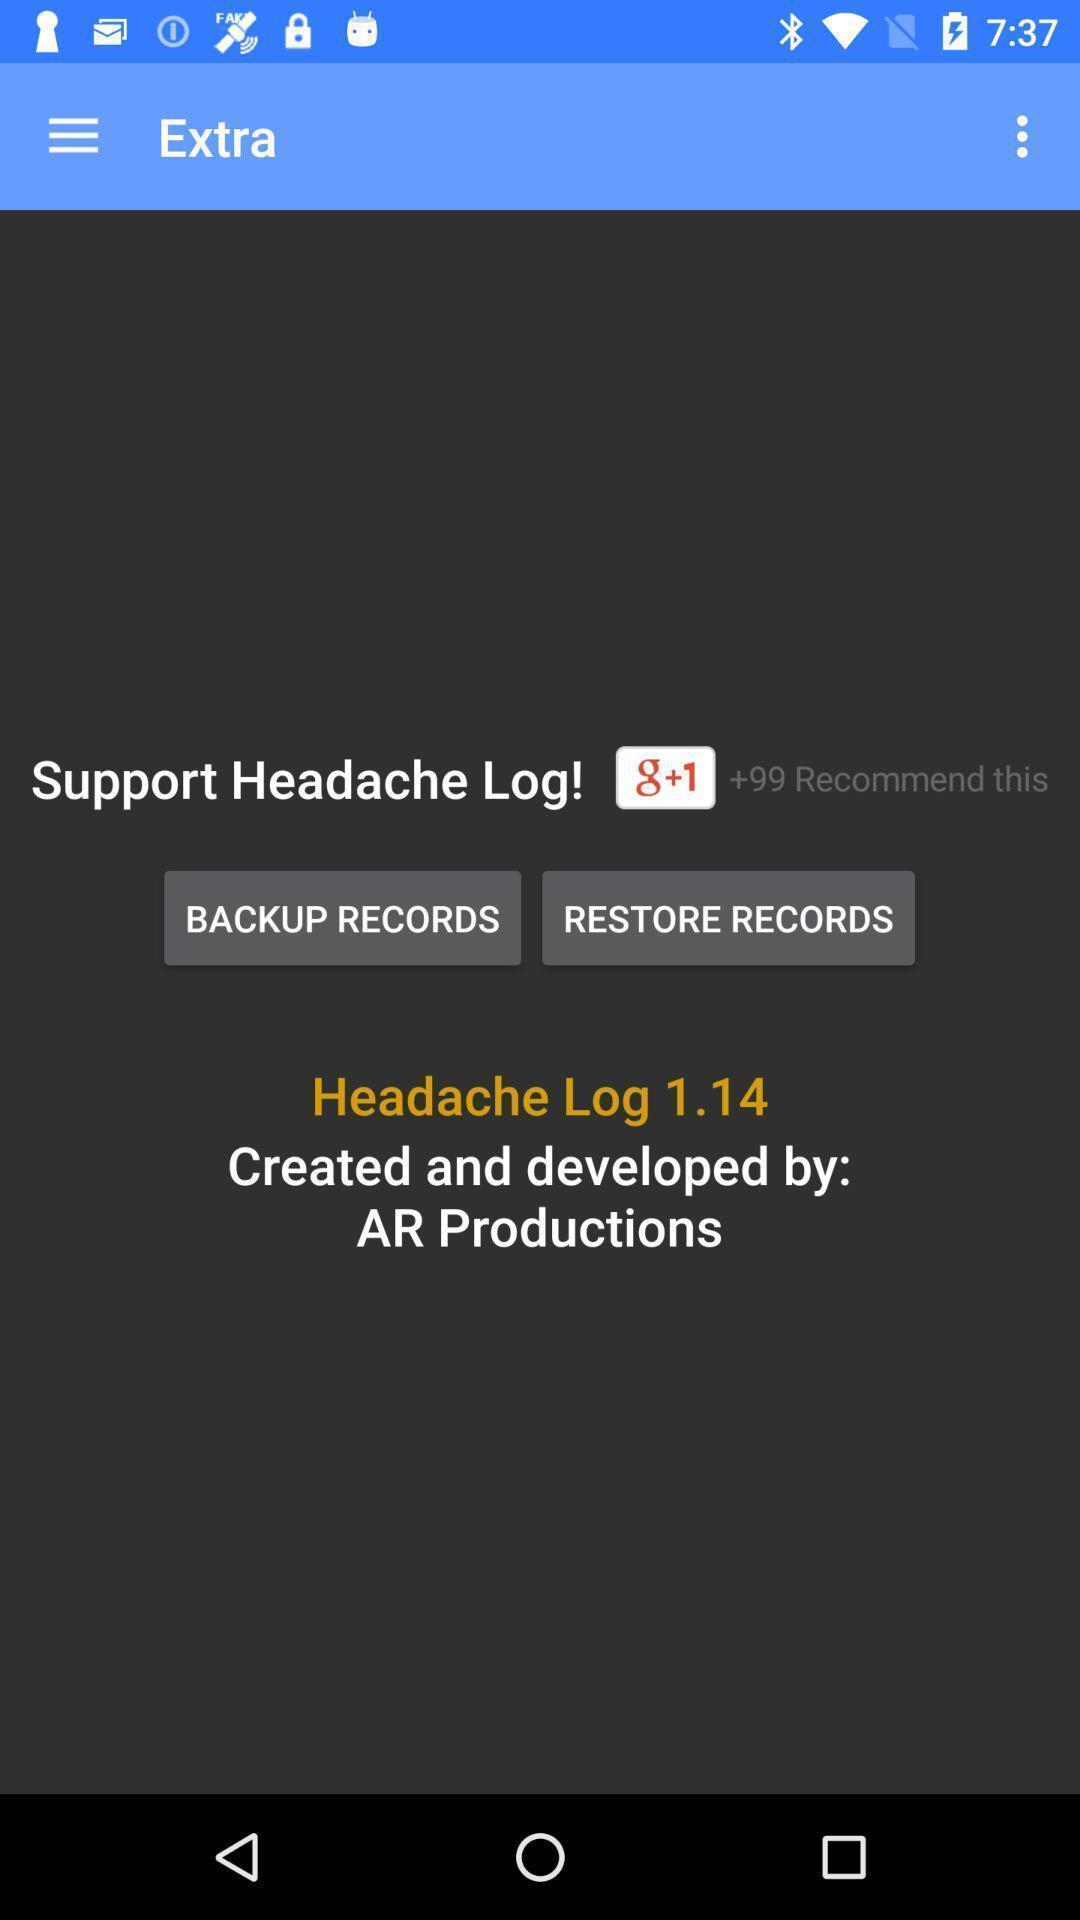Please provide a description for this image. Page with backup and restore records of logs. 